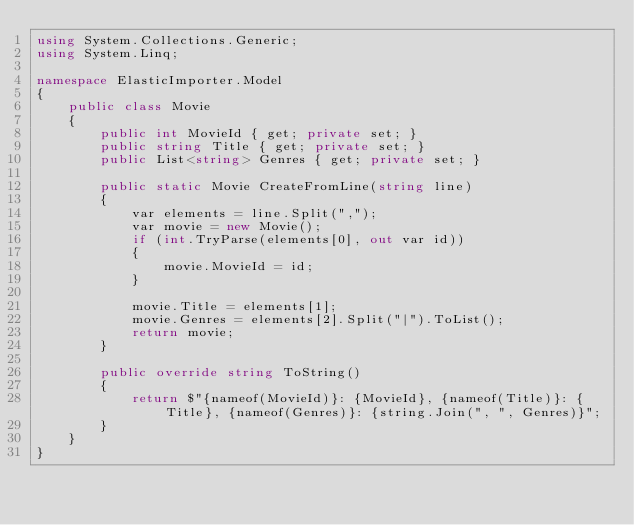Convert code to text. <code><loc_0><loc_0><loc_500><loc_500><_C#_>using System.Collections.Generic;
using System.Linq;

namespace ElasticImporter.Model
{
    public class Movie
    {
        public int MovieId { get; private set; }
        public string Title { get; private set; }
        public List<string> Genres { get; private set; }

        public static Movie CreateFromLine(string line)
        {
            var elements = line.Split(",");
            var movie = new Movie();
            if (int.TryParse(elements[0], out var id))
            {
                movie.MovieId = id;
            }

            movie.Title = elements[1];
            movie.Genres = elements[2].Split("|").ToList();
            return movie;
        }

        public override string ToString()
        {
            return $"{nameof(MovieId)}: {MovieId}, {nameof(Title)}: {Title}, {nameof(Genres)}: {string.Join(", ", Genres)}";
        }
    }
}</code> 